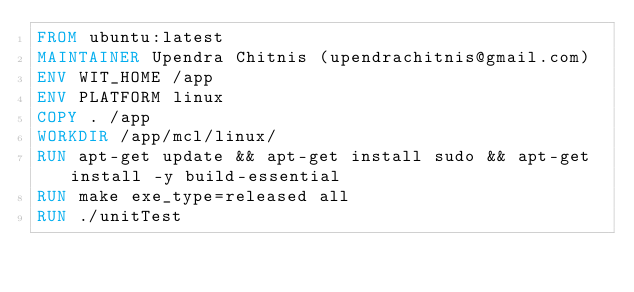Convert code to text. <code><loc_0><loc_0><loc_500><loc_500><_Dockerfile_>FROM ubuntu:latest
MAINTAINER Upendra Chitnis (upendrachitnis@gmail.com)
ENV WIT_HOME /app
ENV PLATFORM linux
COPY . /app
WORKDIR /app/mcl/linux/
RUN apt-get update && apt-get install sudo && apt-get install -y build-essential
RUN make exe_type=released all 
RUN ./unitTest
</code> 